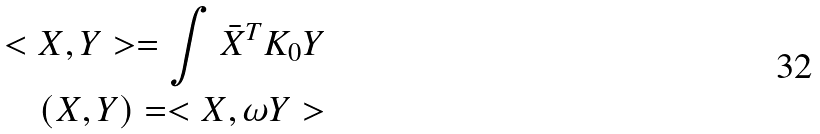Convert formula to latex. <formula><loc_0><loc_0><loc_500><loc_500>< X , Y > = \int \bar { X } ^ { T } K _ { 0 } Y \\ ( X , Y ) = < X , \omega Y ></formula> 